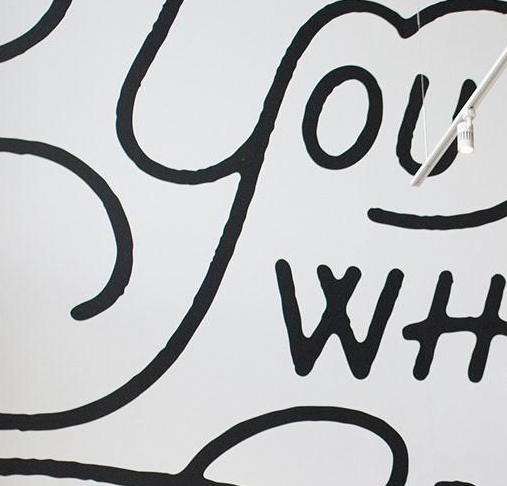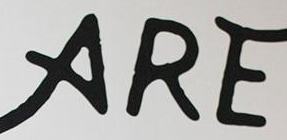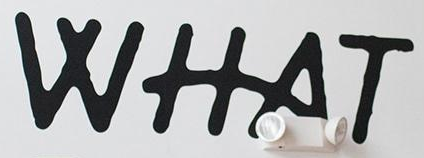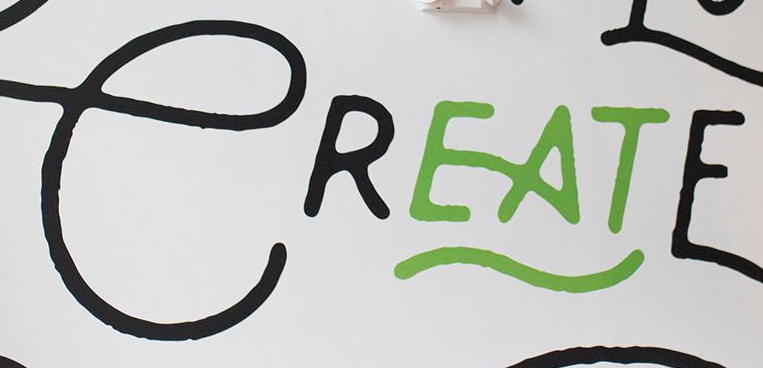What text is displayed in these images sequentially, separated by a semicolon? YOU; ARE; WHAT; CREATE 